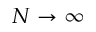Convert formula to latex. <formula><loc_0><loc_0><loc_500><loc_500>N \rightarrow \infty</formula> 